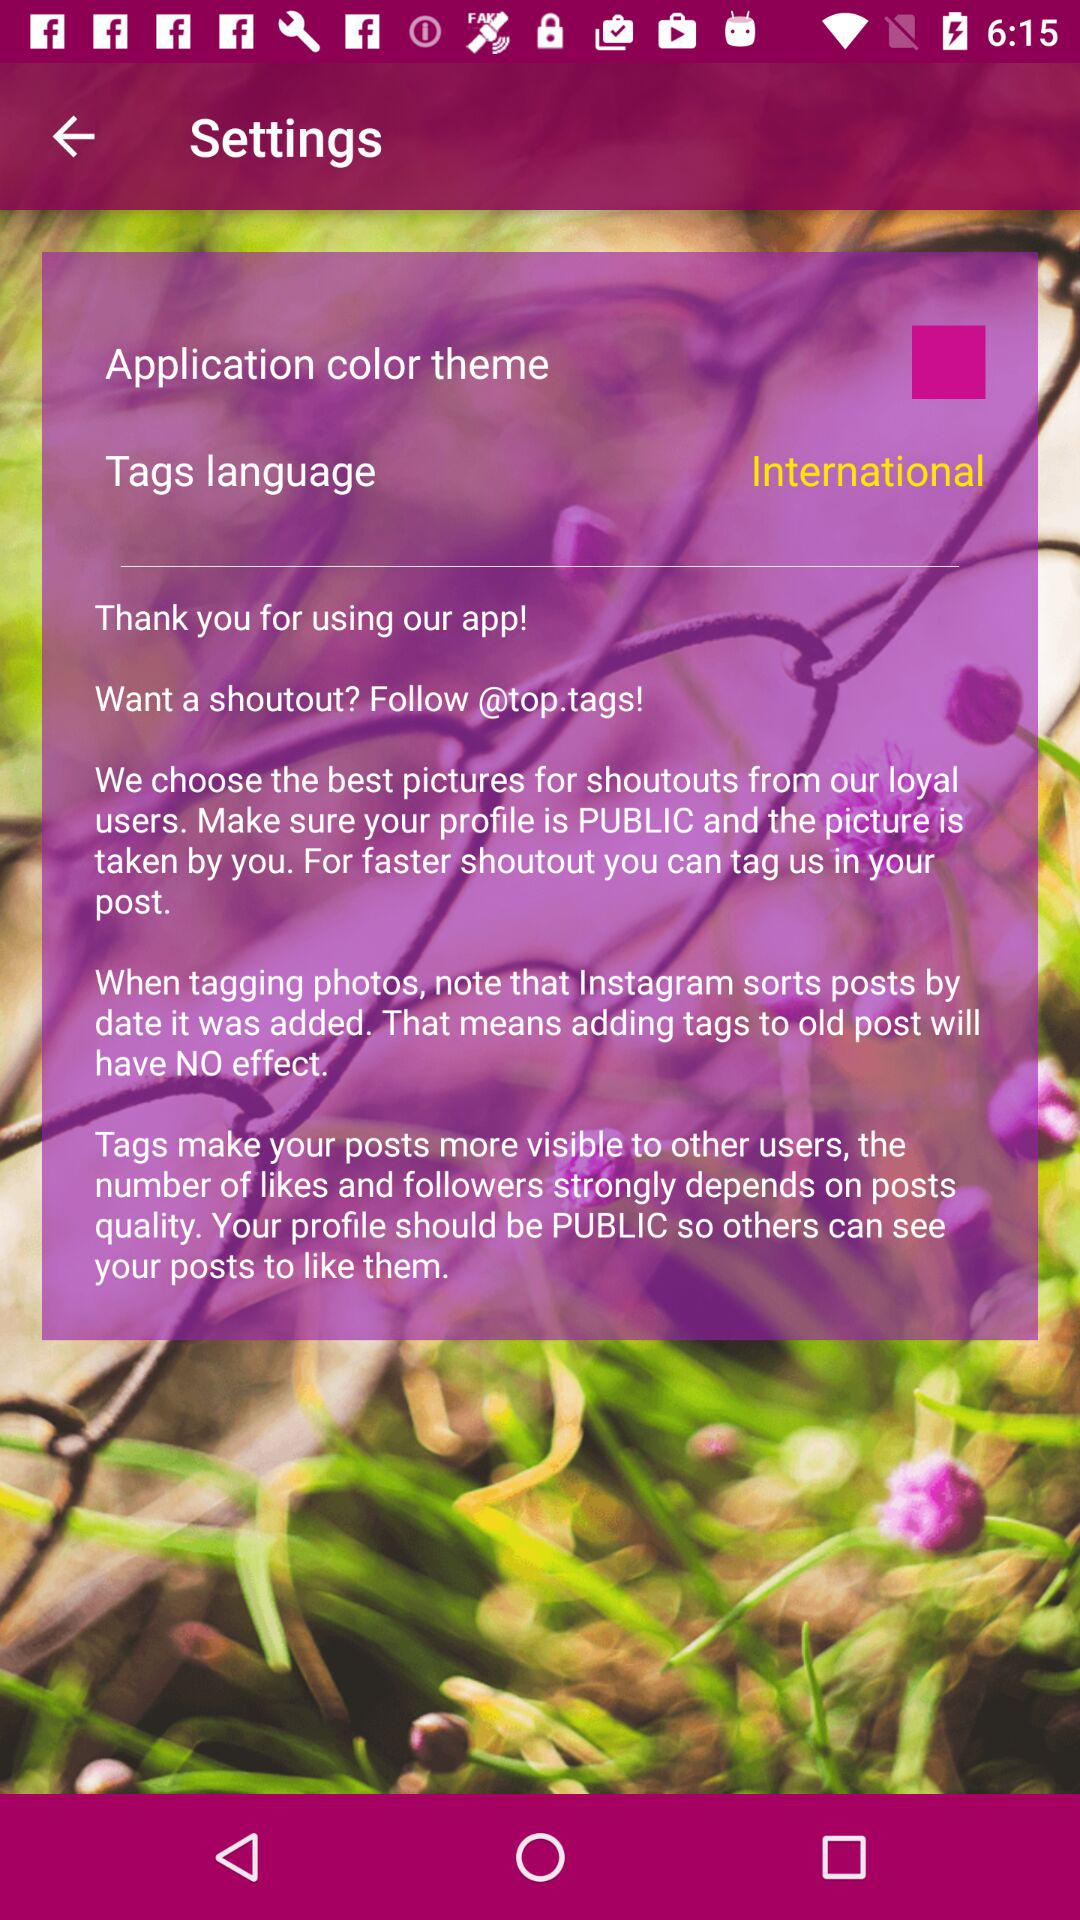What is the selected tag language? The selected tag language is "International". 